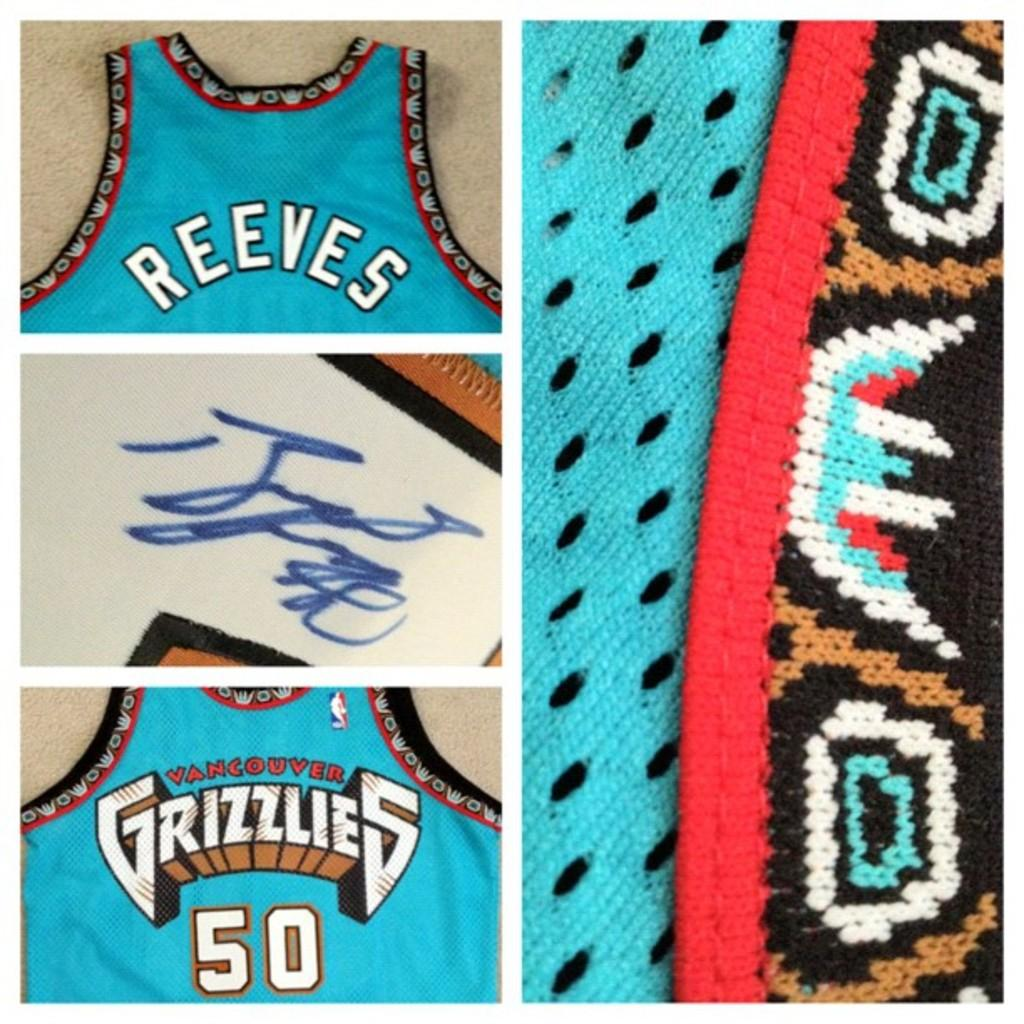<image>
Create a compact narrative representing the image presented. Collage of photos showing a number 50 Grizzles jersey. 